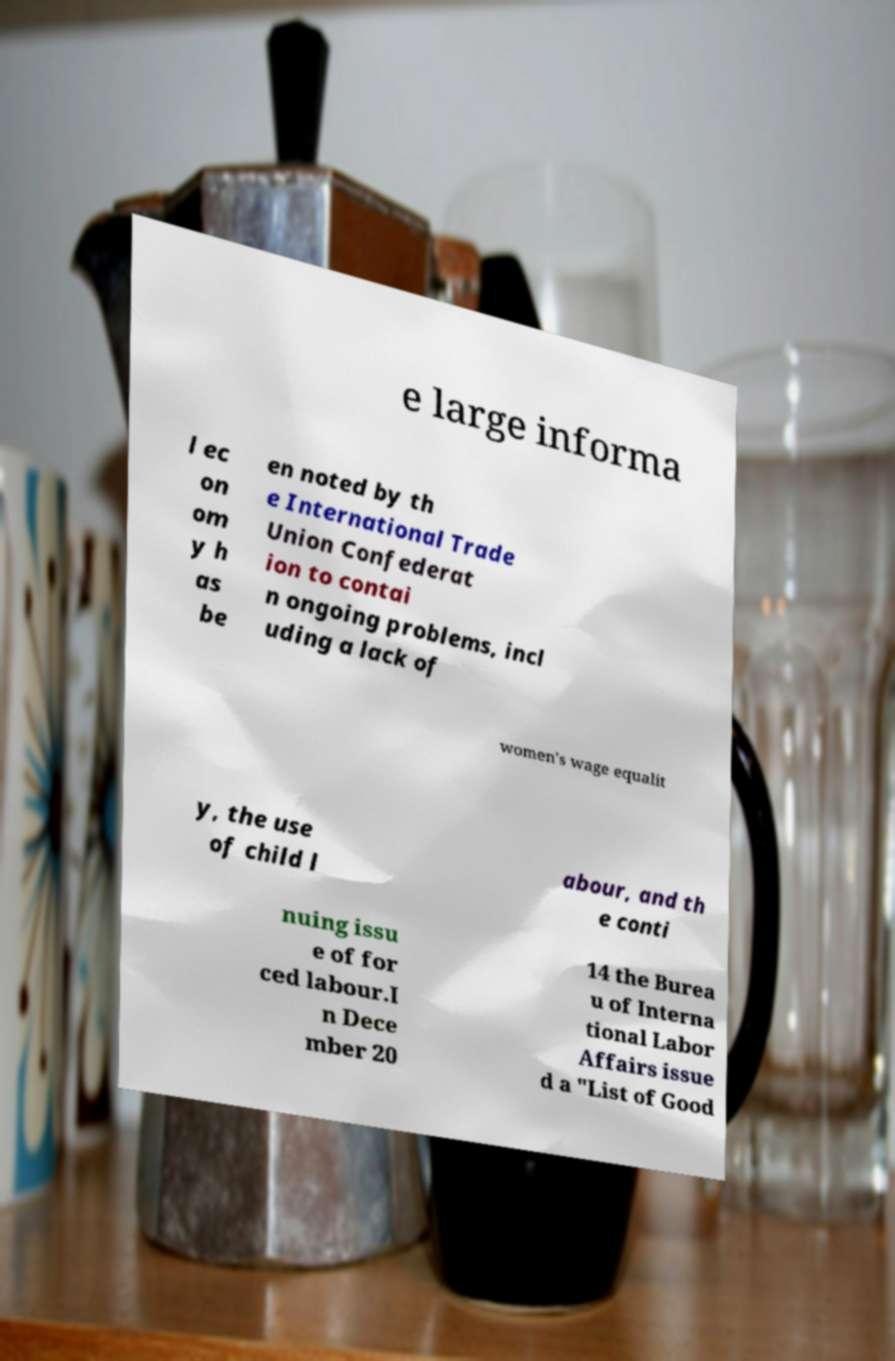There's text embedded in this image that I need extracted. Can you transcribe it verbatim? e large informa l ec on om y h as be en noted by th e International Trade Union Confederat ion to contai n ongoing problems, incl uding a lack of women's wage equalit y, the use of child l abour, and th e conti nuing issu e of for ced labour.I n Dece mber 20 14 the Burea u of Interna tional Labor Affairs issue d a "List of Good 